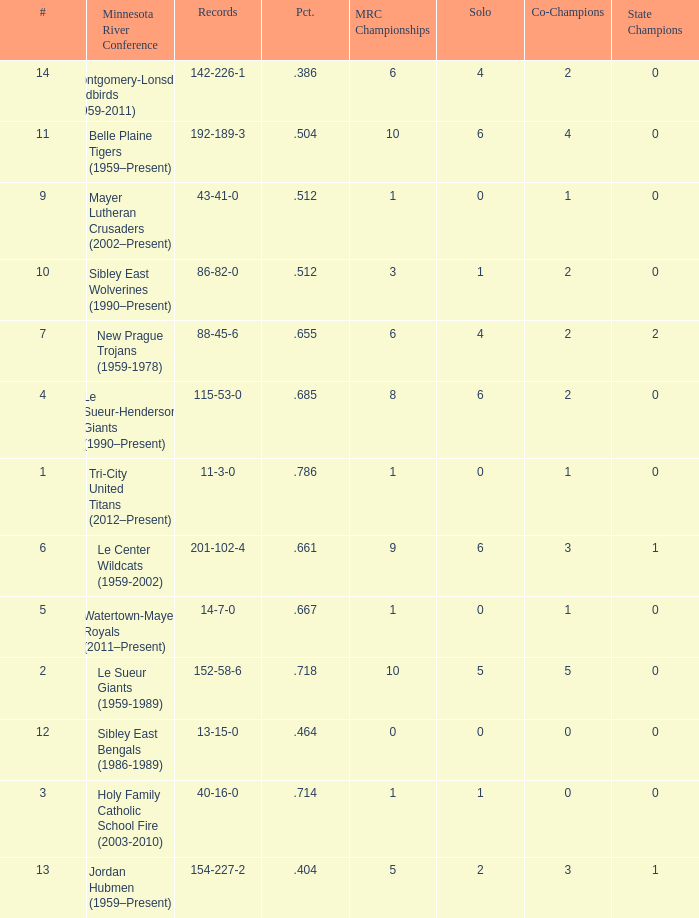How many teams are #2 on the list? 1.0. 